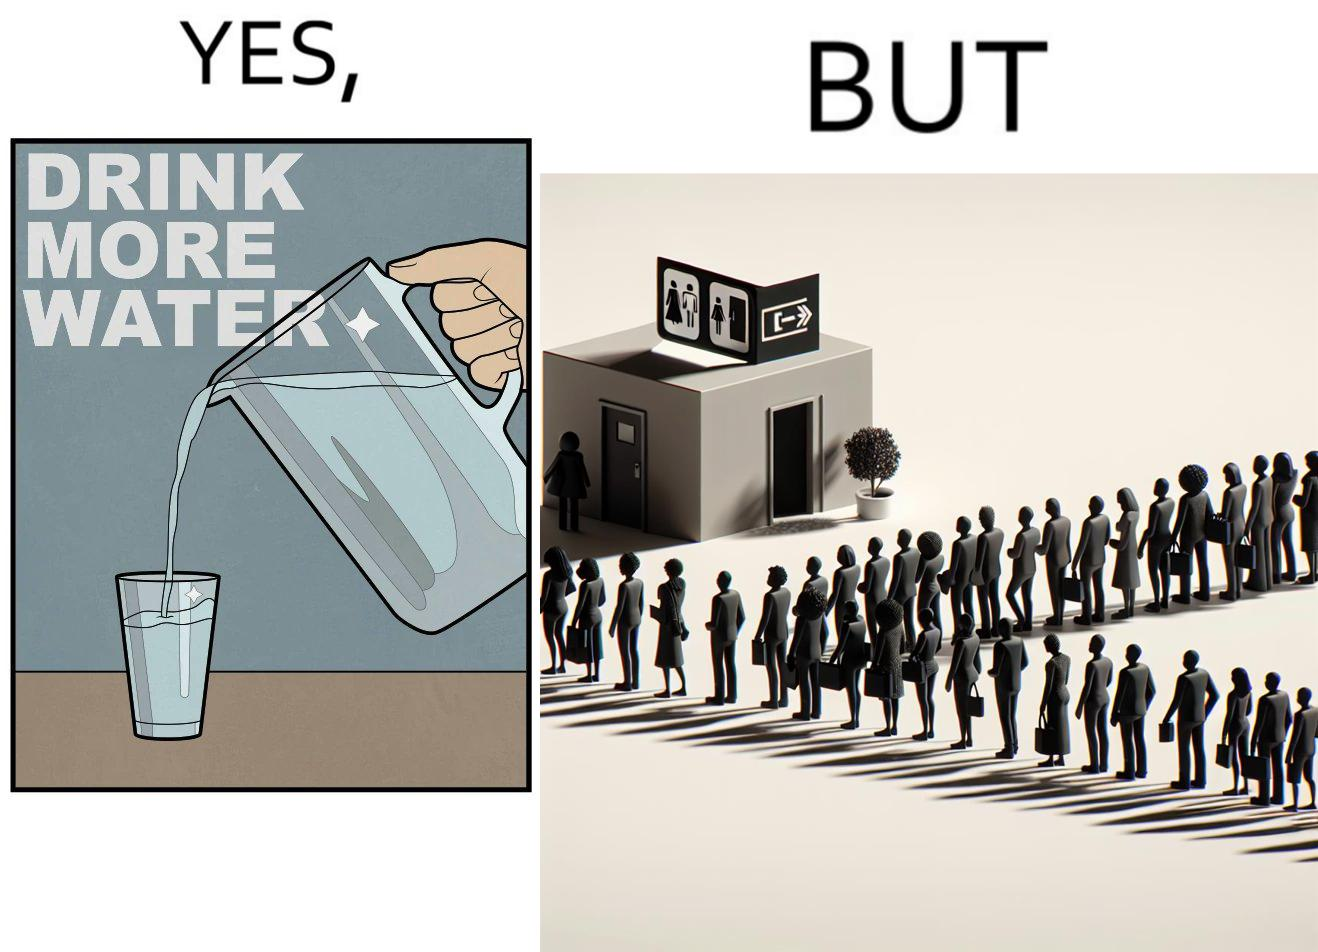What is shown in the left half versus the right half of this image? In the left part of the image: A banner that says "Drink more water" with an image of a jug pouring water into a glass. In the right part of the image: a very long queue in front of the public toilet 